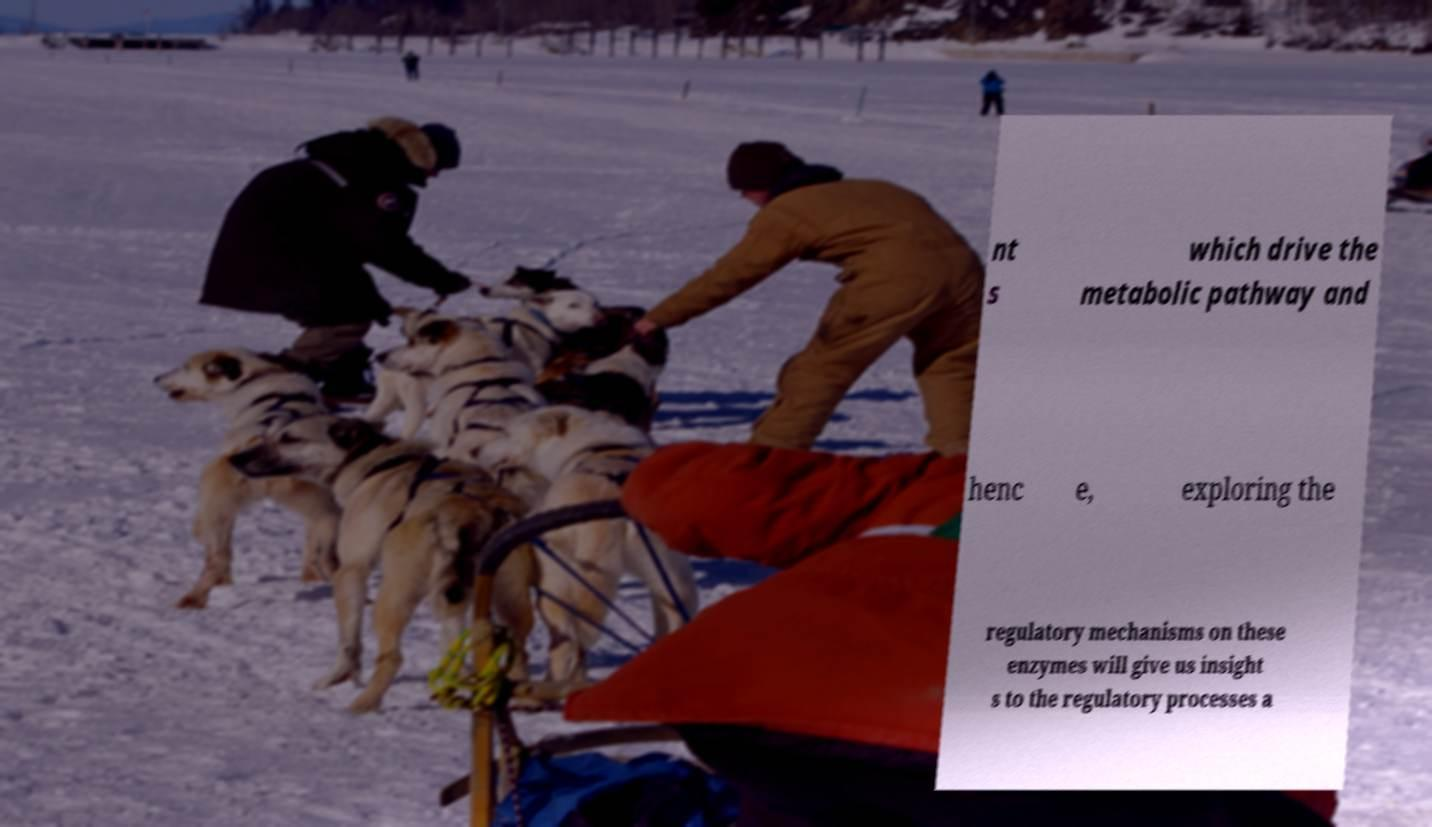Can you read and provide the text displayed in the image?This photo seems to have some interesting text. Can you extract and type it out for me? nt s which drive the metabolic pathway and henc e, exploring the regulatory mechanisms on these enzymes will give us insight s to the regulatory processes a 